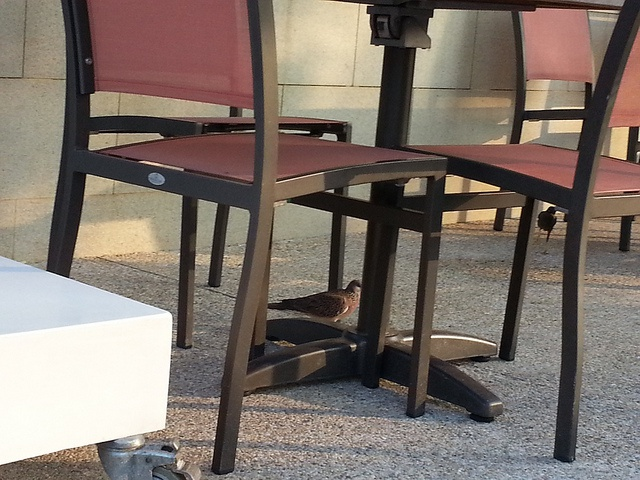Describe the objects in this image and their specific colors. I can see chair in gray, black, brown, and maroon tones, chair in gray, black, brown, and maroon tones, dining table in gray and black tones, chair in gray, salmon, and black tones, and chair in gray and black tones in this image. 